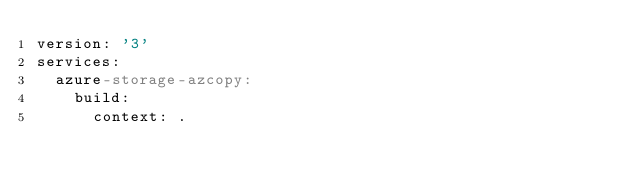Convert code to text. <code><loc_0><loc_0><loc_500><loc_500><_YAML_>version: '3'
services:
  azure-storage-azcopy:
    build:
      context: .</code> 